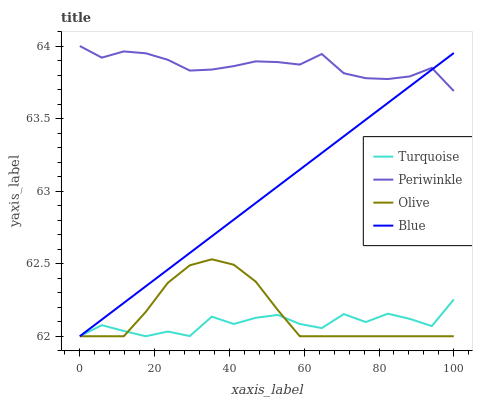Does Turquoise have the minimum area under the curve?
Answer yes or no. Yes. Does Periwinkle have the maximum area under the curve?
Answer yes or no. Yes. Does Blue have the minimum area under the curve?
Answer yes or no. No. Does Blue have the maximum area under the curve?
Answer yes or no. No. Is Blue the smoothest?
Answer yes or no. Yes. Is Turquoise the roughest?
Answer yes or no. Yes. Is Turquoise the smoothest?
Answer yes or no. No. Is Blue the roughest?
Answer yes or no. No. Does Olive have the lowest value?
Answer yes or no. Yes. Does Periwinkle have the lowest value?
Answer yes or no. No. Does Periwinkle have the highest value?
Answer yes or no. Yes. Does Blue have the highest value?
Answer yes or no. No. Is Turquoise less than Periwinkle?
Answer yes or no. Yes. Is Periwinkle greater than Olive?
Answer yes or no. Yes. Does Blue intersect Turquoise?
Answer yes or no. Yes. Is Blue less than Turquoise?
Answer yes or no. No. Is Blue greater than Turquoise?
Answer yes or no. No. Does Turquoise intersect Periwinkle?
Answer yes or no. No. 